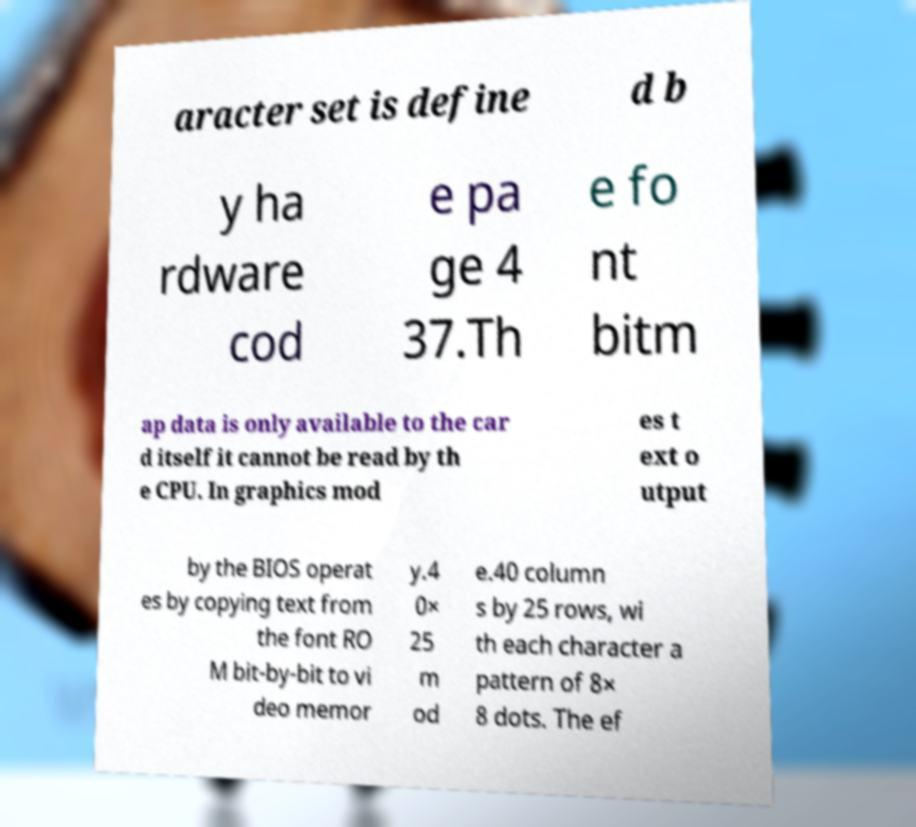I need the written content from this picture converted into text. Can you do that? aracter set is define d b y ha rdware cod e pa ge 4 37.Th e fo nt bitm ap data is only available to the car d itself it cannot be read by th e CPU. In graphics mod es t ext o utput by the BIOS operat es by copying text from the font RO M bit-by-bit to vi deo memor y.4 0× 25 m od e.40 column s by 25 rows, wi th each character a pattern of 8× 8 dots. The ef 